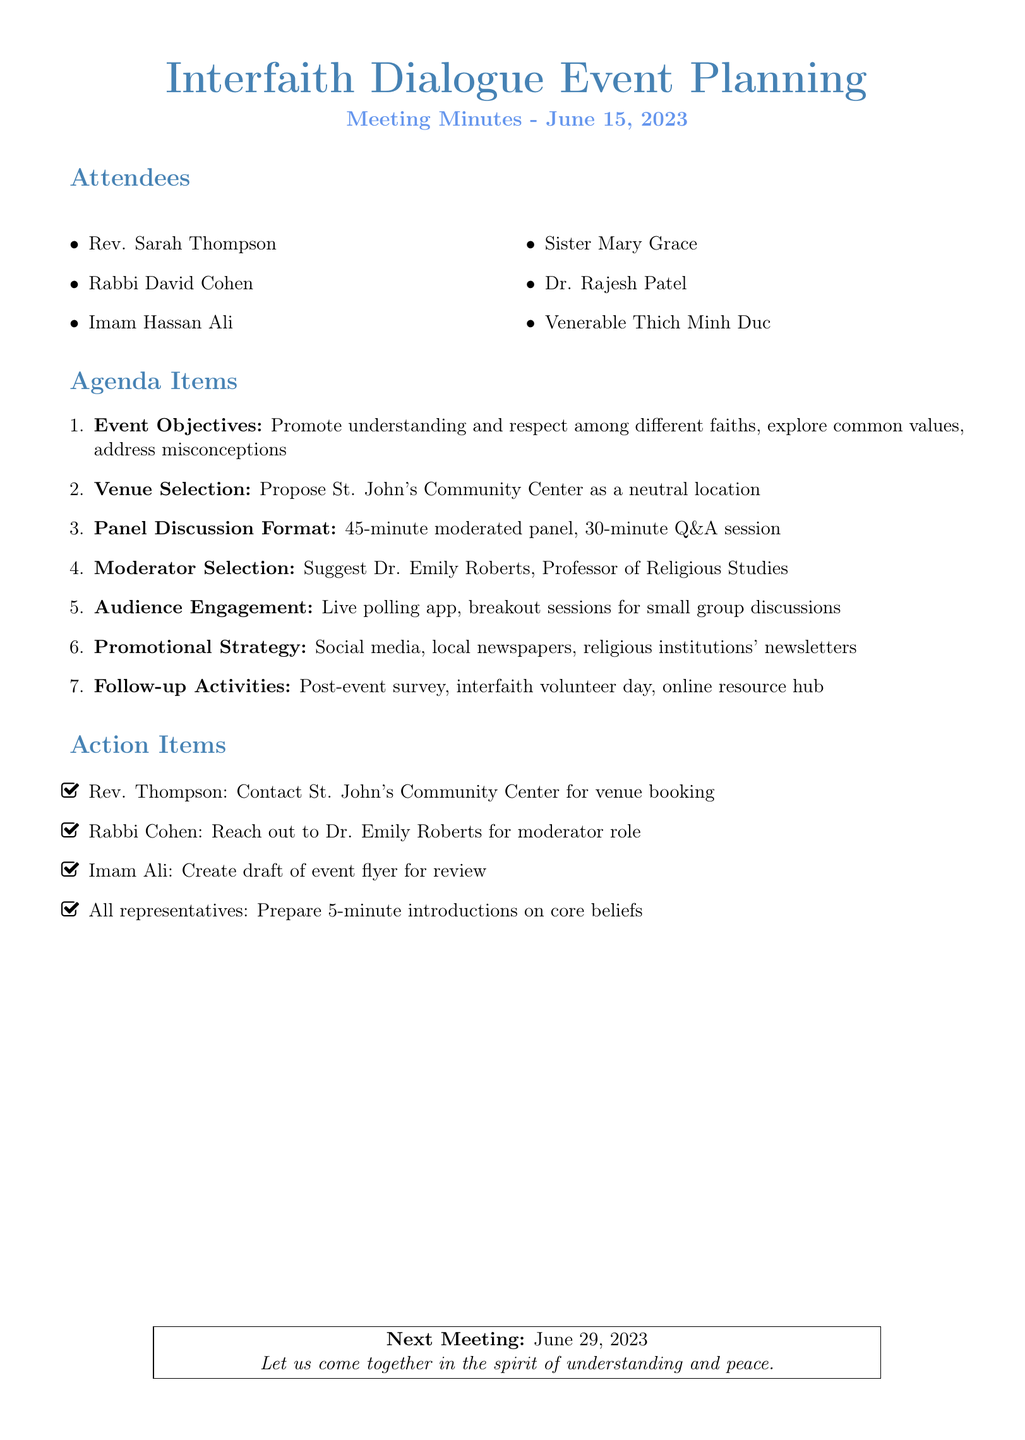What is the meeting title? The meeting title is explicitly stated in the document.
Answer: Interfaith Dialogue Event Planning Who attended the meeting? The document lists all attendees by name and title.
Answer: Rev. Sarah Thompson, Rabbi David Cohen, Imam Hassan Ali, Sister Mary Grace, Dr. Rajesh Patel, Venerable Thich Minh Duc What is the date of the meeting? The date is mentioned at the beginning of the document.
Answer: June 15, 2023 What is the proposed venue for the event? The document specifies the suggested location for the event.
Answer: St. John's Community Center Who is suggested as the moderator for the panel discussion? The document states the name of the suggested moderator.
Answer: Dr. Emily Roberts What is the duration of the panel discussion? The document provides information about the length of the panel discussion.
Answer: 45 minutes What action item is assigned to Rev. Thompson? The document clearly outlines the specific action assigned to each attendee.
Answer: Contact St. John's Community Center for venue booking What follow-up activity is planned after the event? The document lists activities to continue the dialogue after the event.
Answer: Post-event survey 